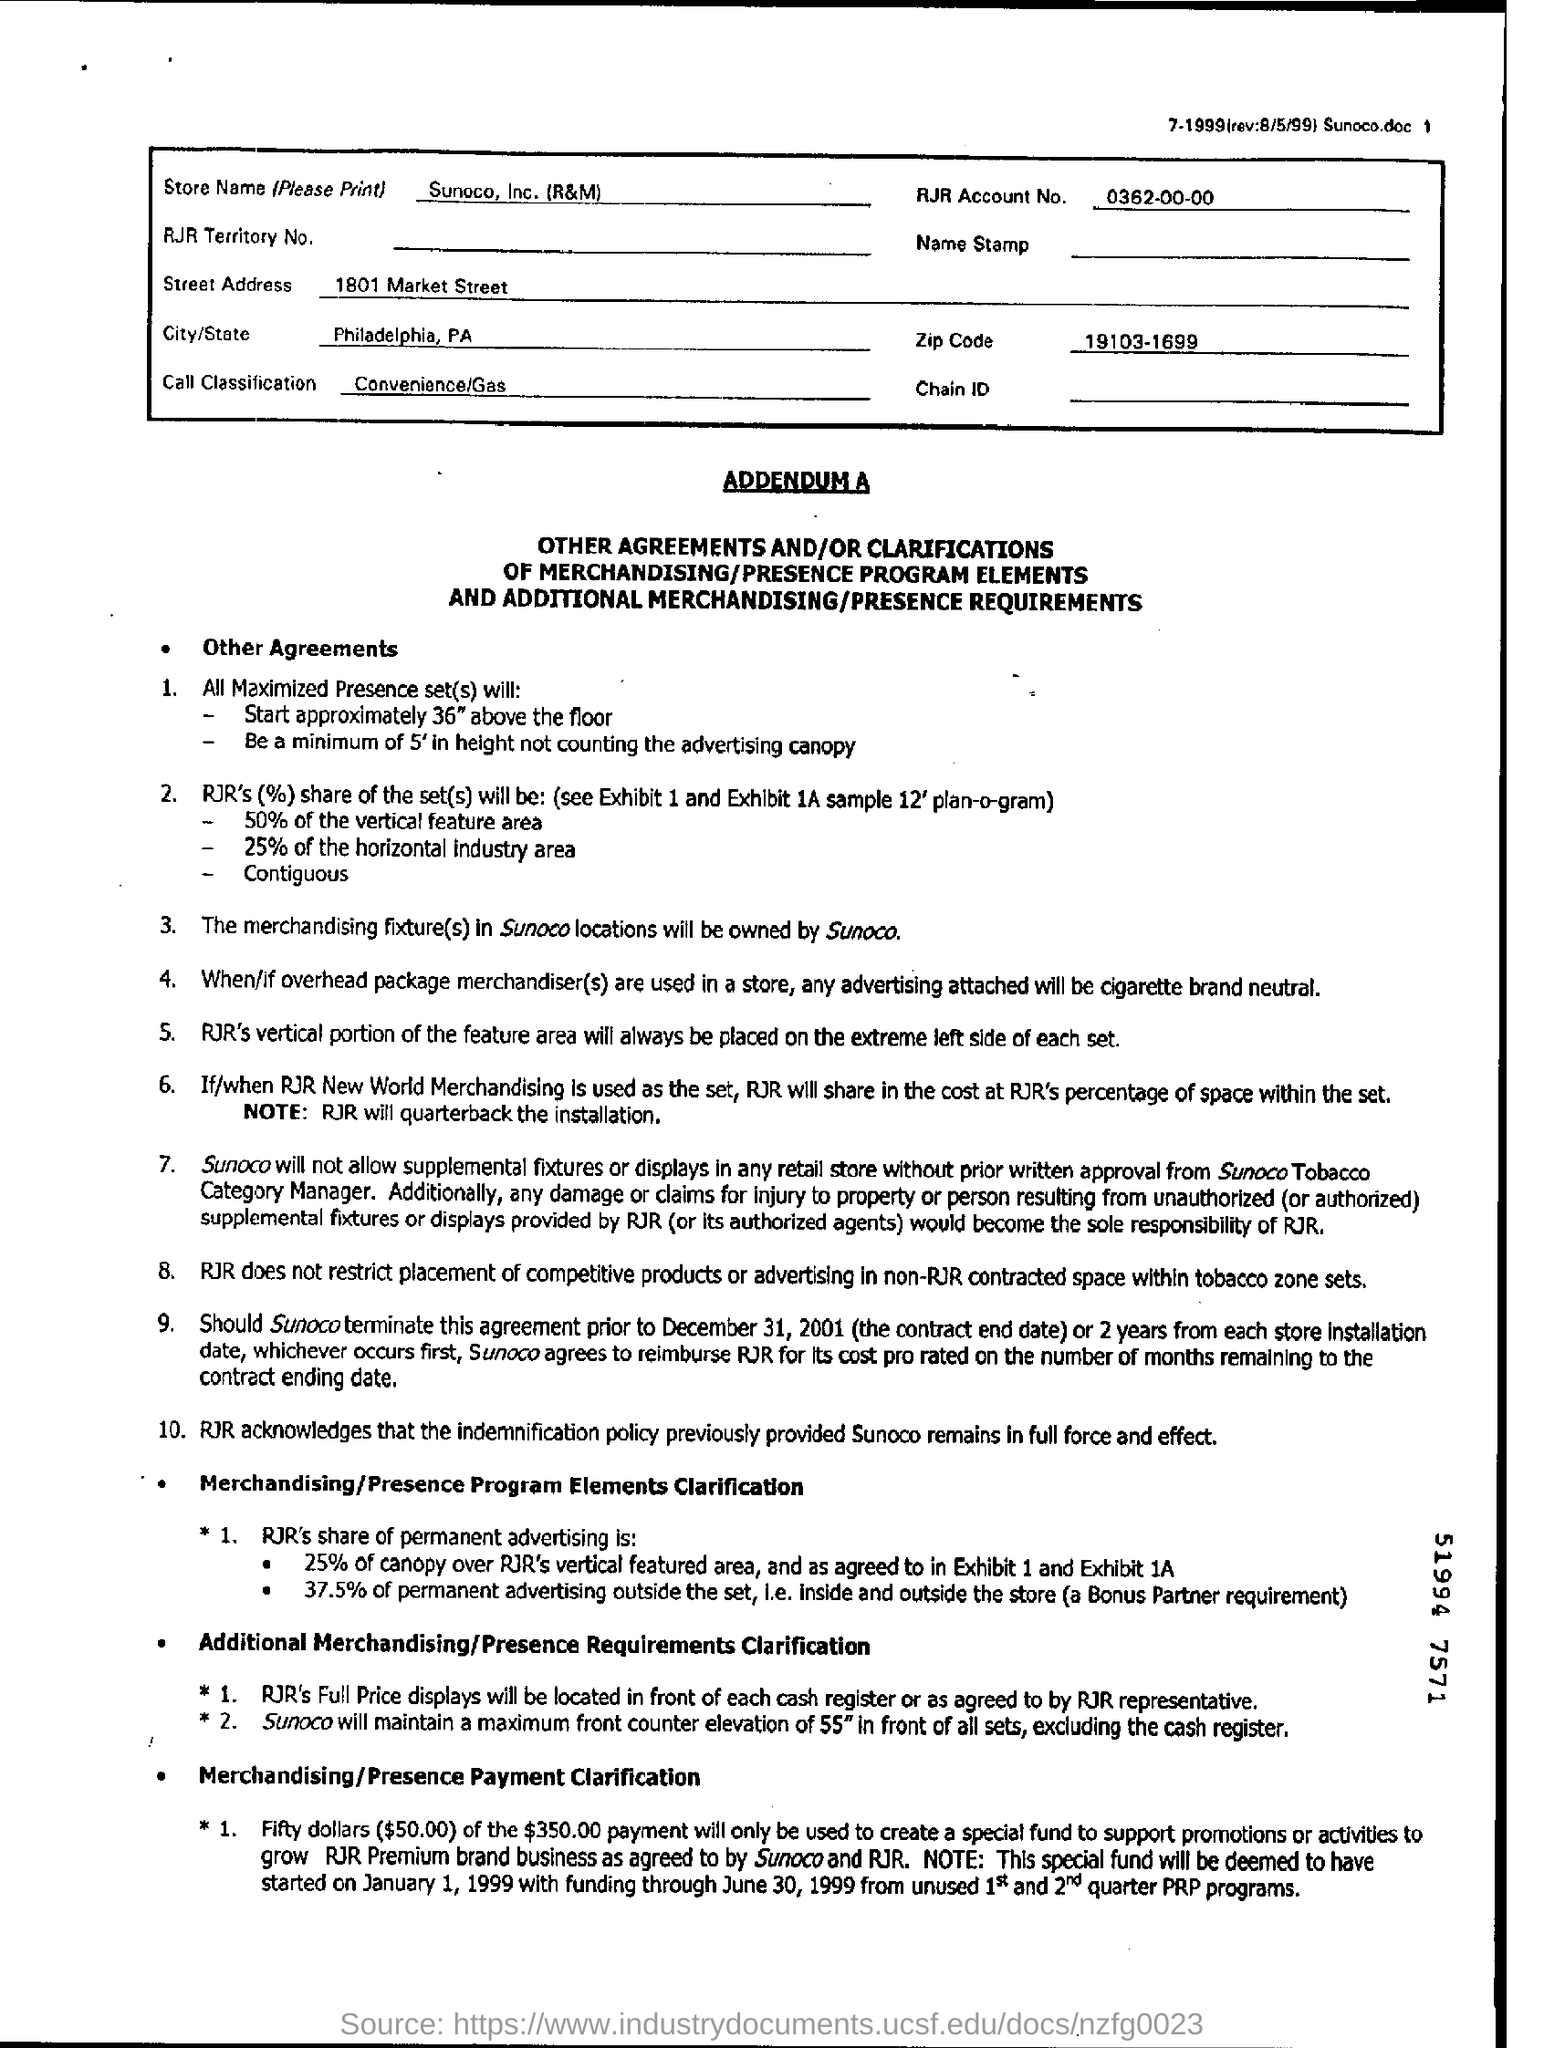Give some essential details in this illustration. The name of the store is Sunoco, Inc. (R&M). The RJR Account number is 0362-00-00, where the first three digits represent the account number, the next two digits represent the branch number, and the final digits represent the account type. 